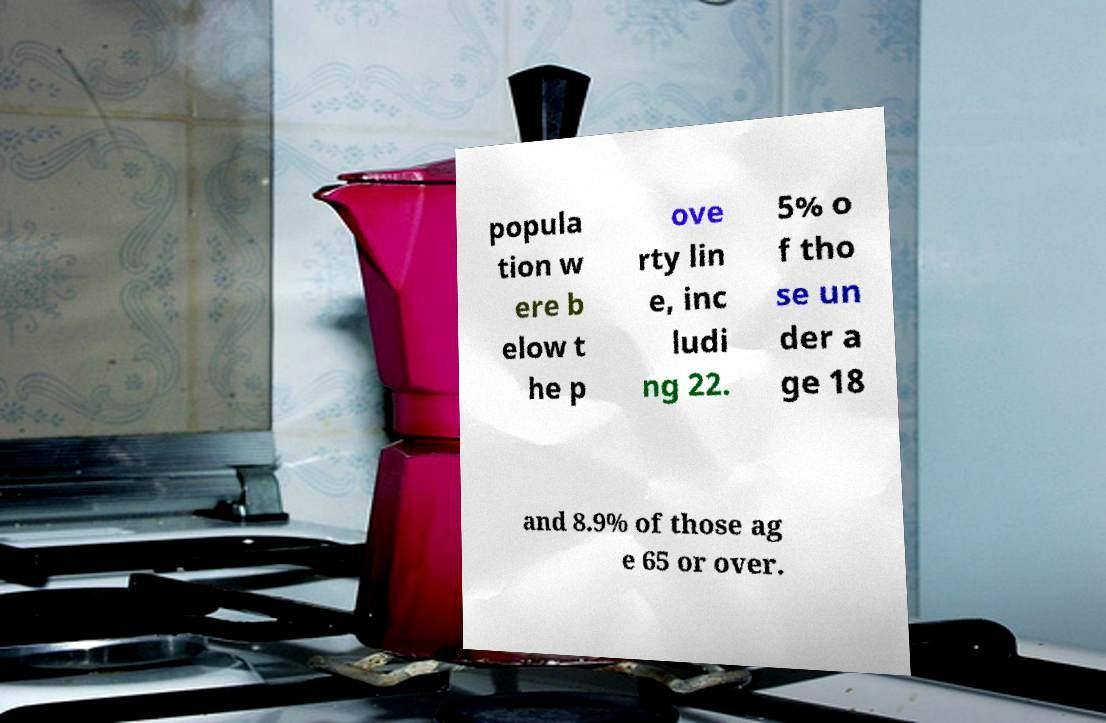Could you assist in decoding the text presented in this image and type it out clearly? popula tion w ere b elow t he p ove rty lin e, inc ludi ng 22. 5% o f tho se un der a ge 18 and 8.9% of those ag e 65 or over. 